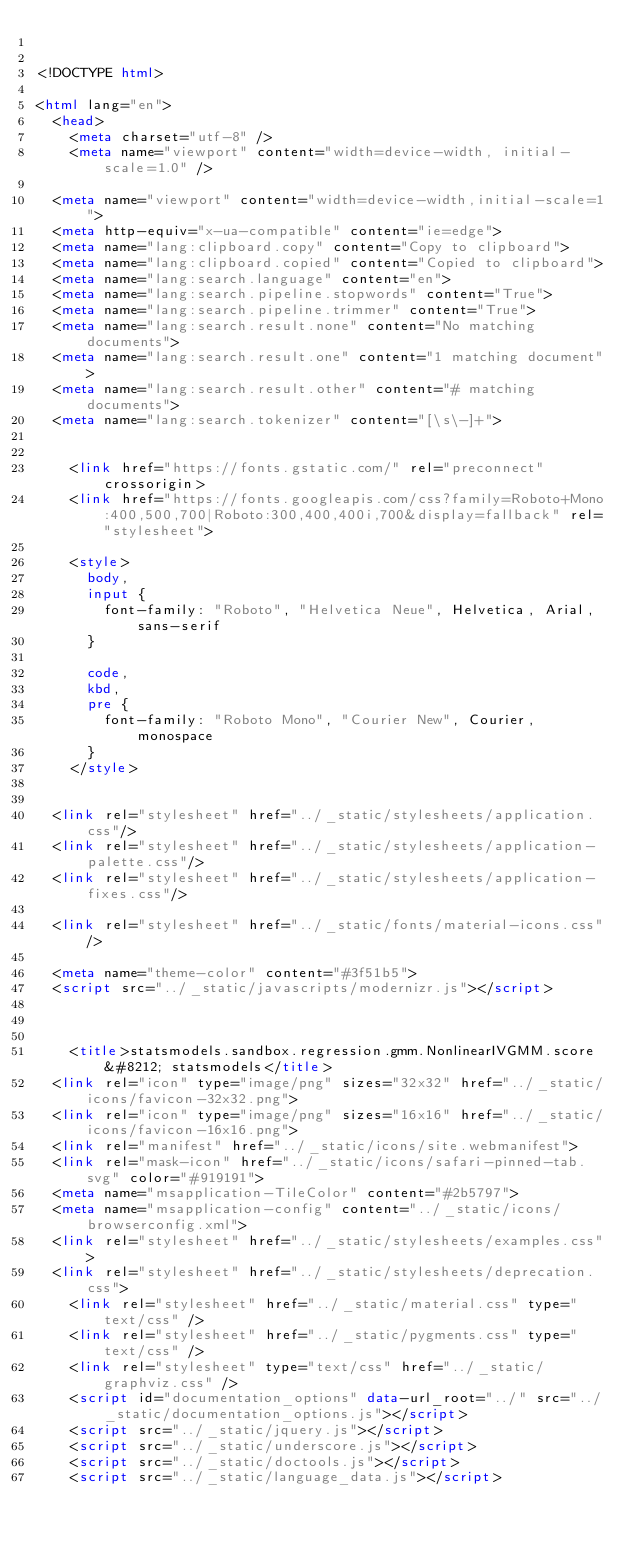Convert code to text. <code><loc_0><loc_0><loc_500><loc_500><_HTML_>

<!DOCTYPE html>

<html lang="en">
  <head>
    <meta charset="utf-8" />
    <meta name="viewport" content="width=device-width, initial-scale=1.0" />
  
  <meta name="viewport" content="width=device-width,initial-scale=1">
  <meta http-equiv="x-ua-compatible" content="ie=edge">
  <meta name="lang:clipboard.copy" content="Copy to clipboard">
  <meta name="lang:clipboard.copied" content="Copied to clipboard">
  <meta name="lang:search.language" content="en">
  <meta name="lang:search.pipeline.stopwords" content="True">
  <meta name="lang:search.pipeline.trimmer" content="True">
  <meta name="lang:search.result.none" content="No matching documents">
  <meta name="lang:search.result.one" content="1 matching document">
  <meta name="lang:search.result.other" content="# matching documents">
  <meta name="lang:search.tokenizer" content="[\s\-]+">

  
    <link href="https://fonts.gstatic.com/" rel="preconnect" crossorigin>
    <link href="https://fonts.googleapis.com/css?family=Roboto+Mono:400,500,700|Roboto:300,400,400i,700&display=fallback" rel="stylesheet">

    <style>
      body,
      input {
        font-family: "Roboto", "Helvetica Neue", Helvetica, Arial, sans-serif
      }

      code,
      kbd,
      pre {
        font-family: "Roboto Mono", "Courier New", Courier, monospace
      }
    </style>
  

  <link rel="stylesheet" href="../_static/stylesheets/application.css"/>
  <link rel="stylesheet" href="../_static/stylesheets/application-palette.css"/>
  <link rel="stylesheet" href="../_static/stylesheets/application-fixes.css"/>
  
  <link rel="stylesheet" href="../_static/fonts/material-icons.css"/>
  
  <meta name="theme-color" content="#3f51b5">
  <script src="../_static/javascripts/modernizr.js"></script>
  
  
  
    <title>statsmodels.sandbox.regression.gmm.NonlinearIVGMM.score &#8212; statsmodels</title>
  <link rel="icon" type="image/png" sizes="32x32" href="../_static/icons/favicon-32x32.png">
  <link rel="icon" type="image/png" sizes="16x16" href="../_static/icons/favicon-16x16.png">
  <link rel="manifest" href="../_static/icons/site.webmanifest">
  <link rel="mask-icon" href="../_static/icons/safari-pinned-tab.svg" color="#919191">
  <meta name="msapplication-TileColor" content="#2b5797">
  <meta name="msapplication-config" content="../_static/icons/browserconfig.xml">
  <link rel="stylesheet" href="../_static/stylesheets/examples.css">
  <link rel="stylesheet" href="../_static/stylesheets/deprecation.css">
    <link rel="stylesheet" href="../_static/material.css" type="text/css" />
    <link rel="stylesheet" href="../_static/pygments.css" type="text/css" />
    <link rel="stylesheet" type="text/css" href="../_static/graphviz.css" />
    <script id="documentation_options" data-url_root="../" src="../_static/documentation_options.js"></script>
    <script src="../_static/jquery.js"></script>
    <script src="../_static/underscore.js"></script>
    <script src="../_static/doctools.js"></script>
    <script src="../_static/language_data.js"></script></code> 